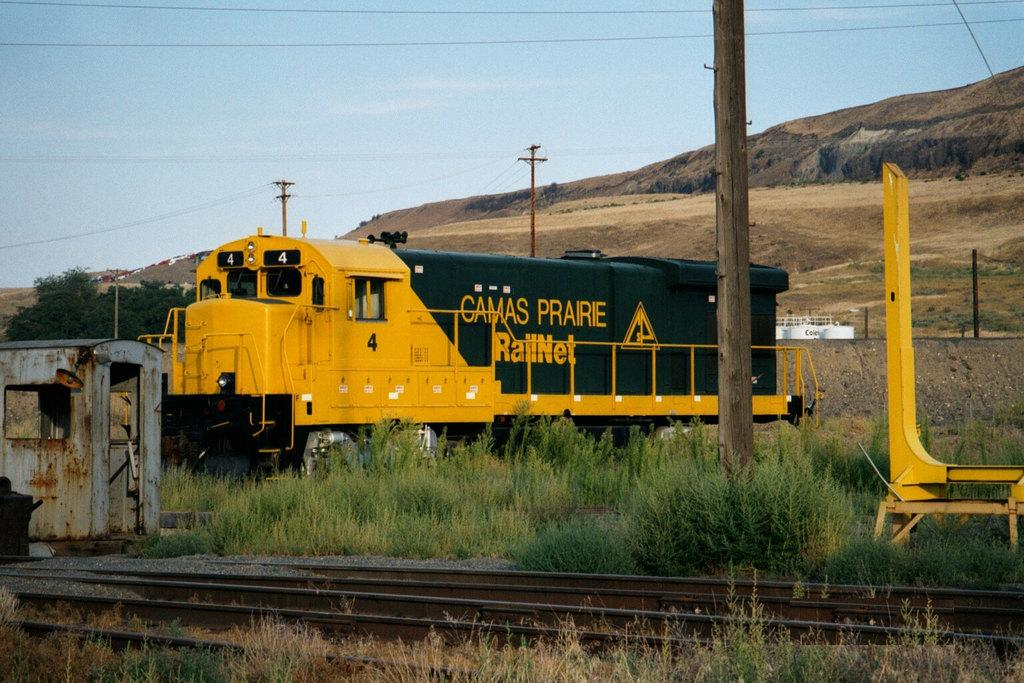<image>
Render a clear and concise summary of the photo. A green and yellow train has "CAMAS PRAIRIE" written on the side 